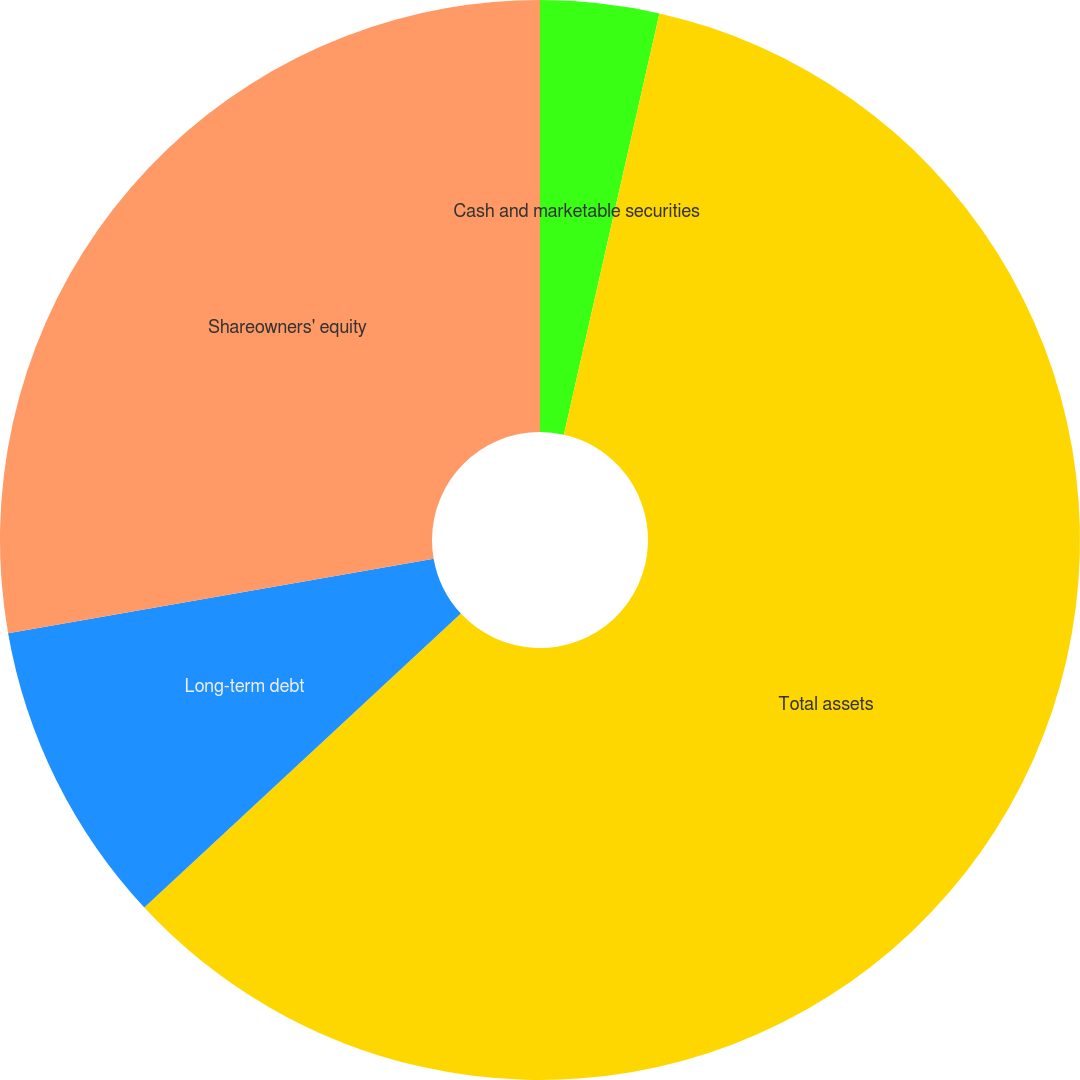<chart> <loc_0><loc_0><loc_500><loc_500><pie_chart><fcel>Cash and marketable securities<fcel>Total assets<fcel>Long-term debt<fcel>Shareowners' equity<nl><fcel>3.55%<fcel>59.54%<fcel>9.15%<fcel>27.76%<nl></chart> 